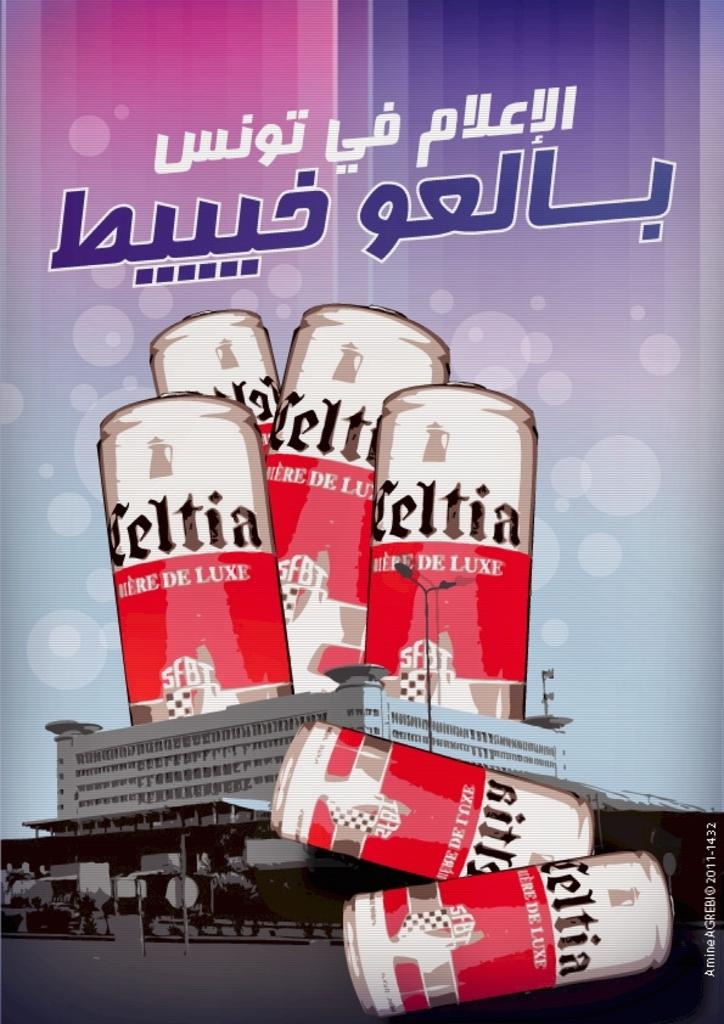<image>
Write a terse but informative summary of the picture. many bottles of beer with the name Celtia. 